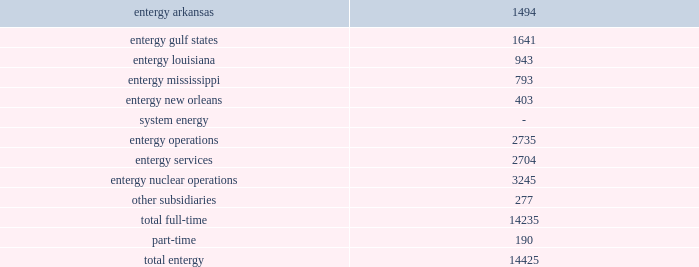Part i item 1 entergy corporation , domestic utility companies , and system energy employment litigation ( entergy corporation , entergy arkansas , entergy gulf states , entergy louisiana , entergy mississippi , entergy new orleans , and system energy ) entergy corporation and the domestic utility companies are defendants in numerous lawsuits that have been filed by former employees alleging that they were wrongfully terminated and/or discriminated against on the basis of age , race , sex , and/or other protected characteristics .
Entergy corporation and the domestic utility companies are vigorously defending these suits and deny any liability to the plaintiffs .
However , no assurance can be given as to the outcome of these cases , and at this time management cannot estimate the total amount of damages sought .
Included in the employment litigation are two cases filed in state court in claiborne county , mississippi in december 2002 .
The two cases were filed by former employees of entergy operations who were based at grand gulf .
Entergy operations and entergy employees are named as defendants .
The cases make employment-related claims , and seek in total $ 53 million in alleged actual damages and $ 168 million in punitive damages .
Entergy subsequently removed both proceedings to the federal district in jackson , mississippi .
Entergy cannot predict the ultimate outcome of this proceeding .
Research spending entergy is a member of the electric power research institute ( epri ) .
Epri conducts a broad range of research in major technical fields related to the electric utility industry .
Entergy participates in various epri projects based on entergy's needs and available resources .
The domestic utility companies contributed $ 1.6 million in 2004 , $ 1.5 million in 2003 , and $ 2.1 million in 2002 to epri .
The non-utility nuclear business contributed $ 3.2 million in 2004 and $ 3 million in both 2003 and 2002 to epri .
Employees employees are an integral part of entergy's commitment to serving its customers .
As of december 31 , 2004 , entergy employed 14425 people .
U.s .
Utility: .
Approximately 4900 employees are represented by the international brotherhood of electrical workers union , the utility workers union of america , and the international brotherhood of teamsters union. .
What percent of total full-time employees are in entergy nuclear operations? 
Computations: (3245 / 14235)
Answer: 0.22796. 